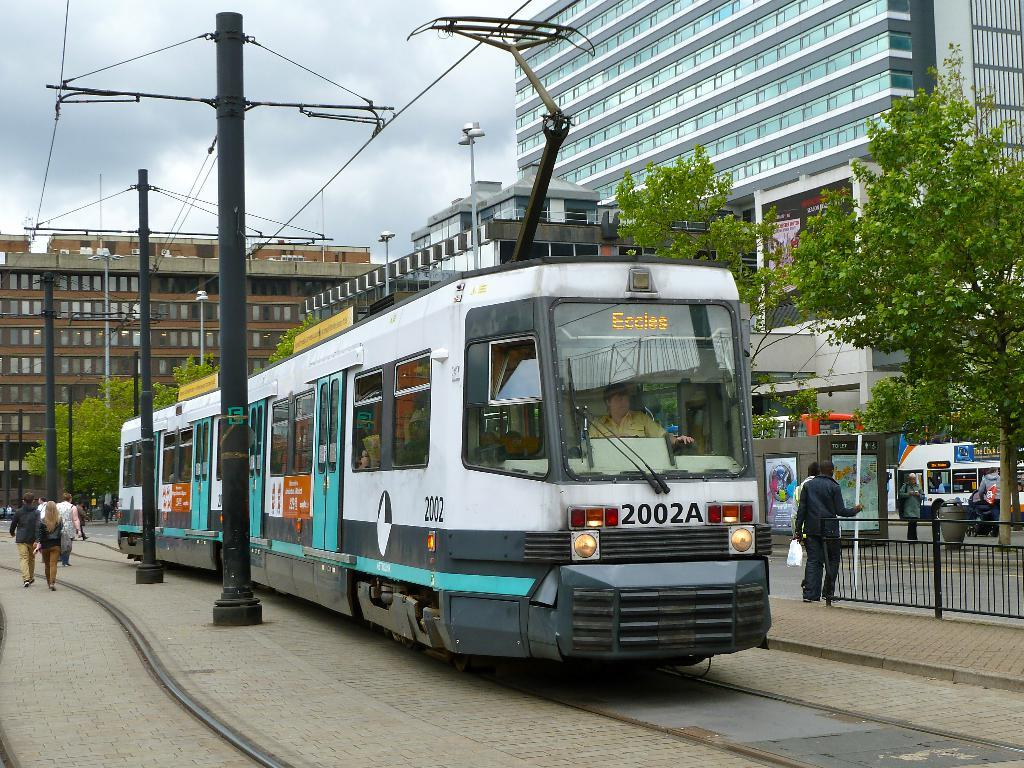Provide a one-sentence caption for the provided image. A streetcar with 2002A on the front heading for Eccles. 